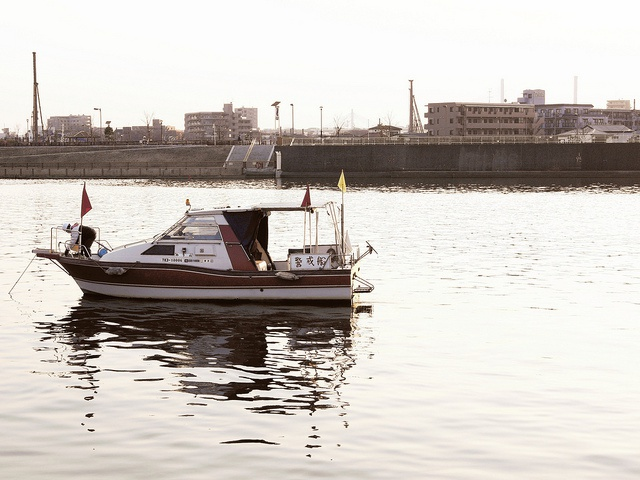Describe the objects in this image and their specific colors. I can see boat in white, black, darkgray, and gray tones and people in white, black, darkgray, and gray tones in this image. 